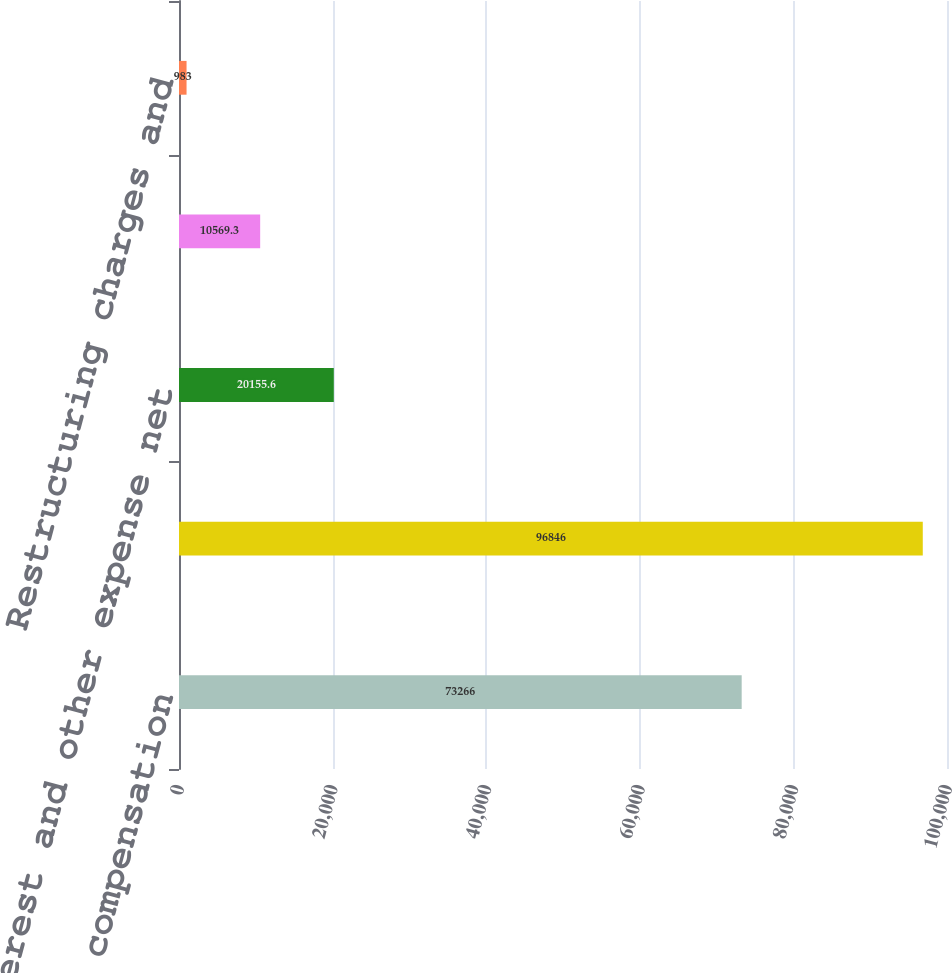Convert chart. <chart><loc_0><loc_0><loc_500><loc_500><bar_chart><fcel>Stock-based compensation<fcel>expense<fcel>Interest and other expense net<fcel>Provision (benefit) for income<fcel>Restructuring charges and<nl><fcel>73266<fcel>96846<fcel>20155.6<fcel>10569.3<fcel>983<nl></chart> 